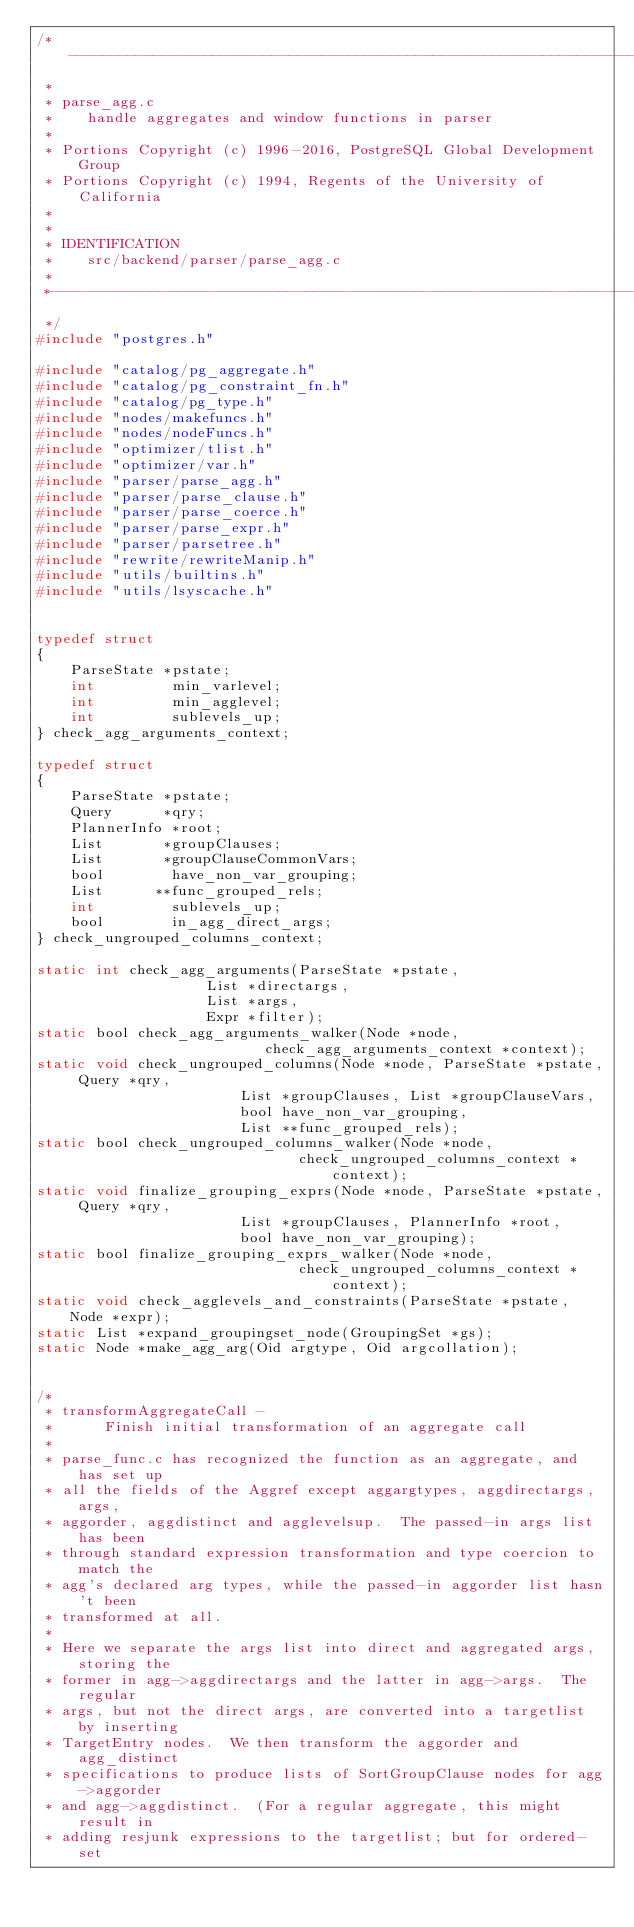Convert code to text. <code><loc_0><loc_0><loc_500><loc_500><_C_>/*-------------------------------------------------------------------------
 *
 * parse_agg.c
 *	  handle aggregates and window functions in parser
 *
 * Portions Copyright (c) 1996-2016, PostgreSQL Global Development Group
 * Portions Copyright (c) 1994, Regents of the University of California
 *
 *
 * IDENTIFICATION
 *	  src/backend/parser/parse_agg.c
 *
 *-------------------------------------------------------------------------
 */
#include "postgres.h"

#include "catalog/pg_aggregate.h"
#include "catalog/pg_constraint_fn.h"
#include "catalog/pg_type.h"
#include "nodes/makefuncs.h"
#include "nodes/nodeFuncs.h"
#include "optimizer/tlist.h"
#include "optimizer/var.h"
#include "parser/parse_agg.h"
#include "parser/parse_clause.h"
#include "parser/parse_coerce.h"
#include "parser/parse_expr.h"
#include "parser/parsetree.h"
#include "rewrite/rewriteManip.h"
#include "utils/builtins.h"
#include "utils/lsyscache.h"


typedef struct
{
	ParseState *pstate;
	int			min_varlevel;
	int			min_agglevel;
	int			sublevels_up;
} check_agg_arguments_context;

typedef struct
{
	ParseState *pstate;
	Query	   *qry;
	PlannerInfo *root;
	List	   *groupClauses;
	List	   *groupClauseCommonVars;
	bool		have_non_var_grouping;
	List	  **func_grouped_rels;
	int			sublevels_up;
	bool		in_agg_direct_args;
} check_ungrouped_columns_context;

static int check_agg_arguments(ParseState *pstate,
					List *directargs,
					List *args,
					Expr *filter);
static bool check_agg_arguments_walker(Node *node,
						   check_agg_arguments_context *context);
static void check_ungrouped_columns(Node *node, ParseState *pstate, Query *qry,
						List *groupClauses, List *groupClauseVars,
						bool have_non_var_grouping,
						List **func_grouped_rels);
static bool check_ungrouped_columns_walker(Node *node,
							   check_ungrouped_columns_context *context);
static void finalize_grouping_exprs(Node *node, ParseState *pstate, Query *qry,
						List *groupClauses, PlannerInfo *root,
						bool have_non_var_grouping);
static bool finalize_grouping_exprs_walker(Node *node,
							   check_ungrouped_columns_context *context);
static void check_agglevels_and_constraints(ParseState *pstate, Node *expr);
static List *expand_groupingset_node(GroupingSet *gs);
static Node *make_agg_arg(Oid argtype, Oid argcollation);


/*
 * transformAggregateCall -
 *		Finish initial transformation of an aggregate call
 *
 * parse_func.c has recognized the function as an aggregate, and has set up
 * all the fields of the Aggref except aggargtypes, aggdirectargs, args,
 * aggorder, aggdistinct and agglevelsup.  The passed-in args list has been
 * through standard expression transformation and type coercion to match the
 * agg's declared arg types, while the passed-in aggorder list hasn't been
 * transformed at all.
 *
 * Here we separate the args list into direct and aggregated args, storing the
 * former in agg->aggdirectargs and the latter in agg->args.  The regular
 * args, but not the direct args, are converted into a targetlist by inserting
 * TargetEntry nodes.  We then transform the aggorder and agg_distinct
 * specifications to produce lists of SortGroupClause nodes for agg->aggorder
 * and agg->aggdistinct.  (For a regular aggregate, this might result in
 * adding resjunk expressions to the targetlist; but for ordered-set</code> 